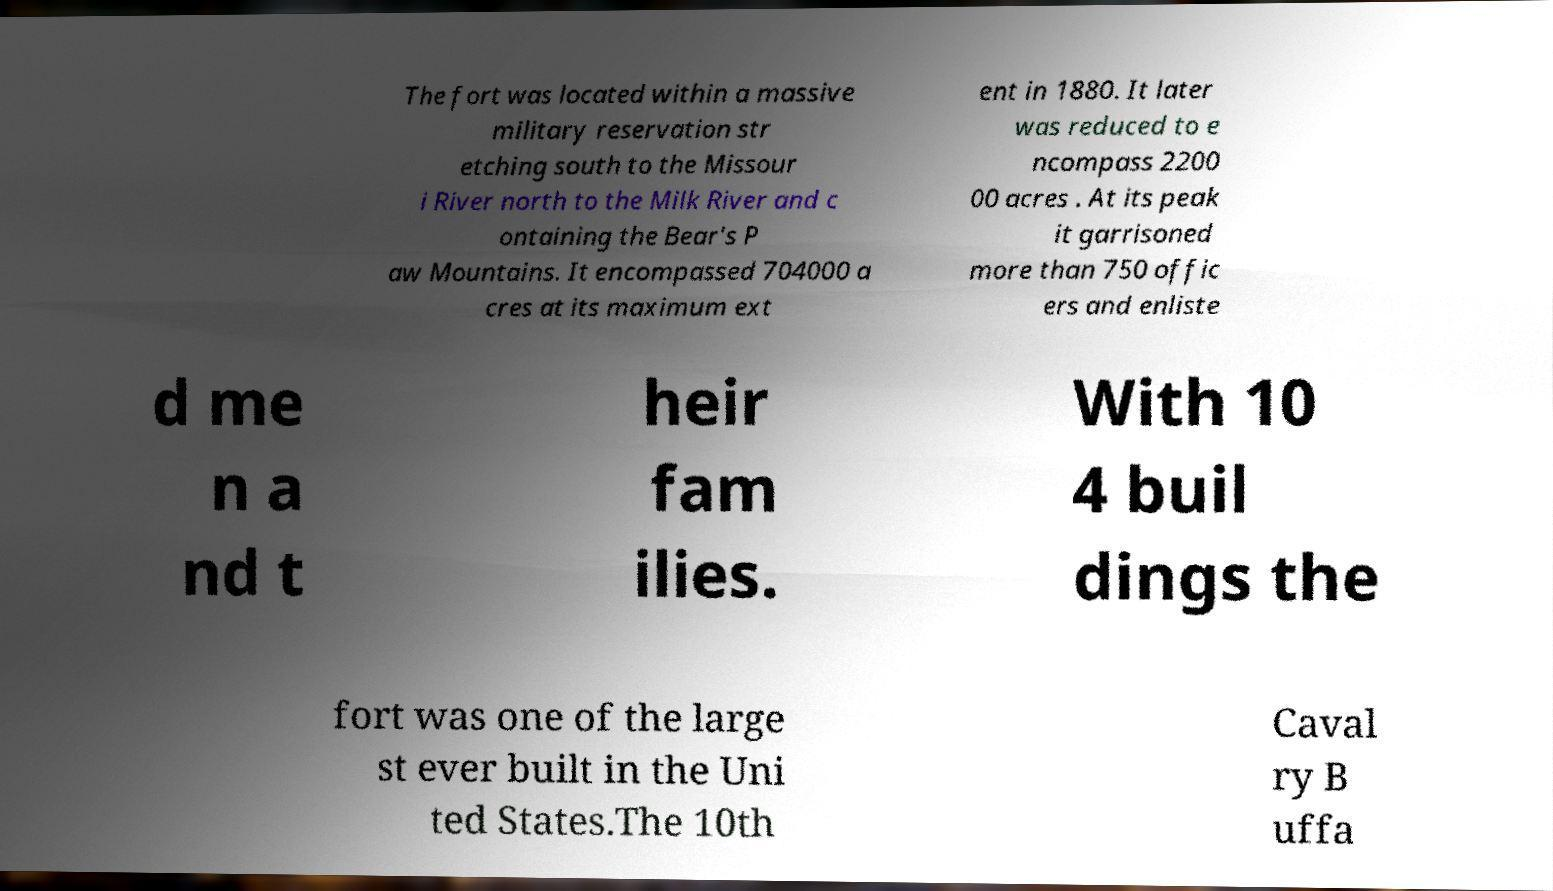For documentation purposes, I need the text within this image transcribed. Could you provide that? The fort was located within a massive military reservation str etching south to the Missour i River north to the Milk River and c ontaining the Bear's P aw Mountains. It encompassed 704000 a cres at its maximum ext ent in 1880. It later was reduced to e ncompass 2200 00 acres . At its peak it garrisoned more than 750 offic ers and enliste d me n a nd t heir fam ilies. With 10 4 buil dings the fort was one of the large st ever built in the Uni ted States.The 10th Caval ry B uffa 